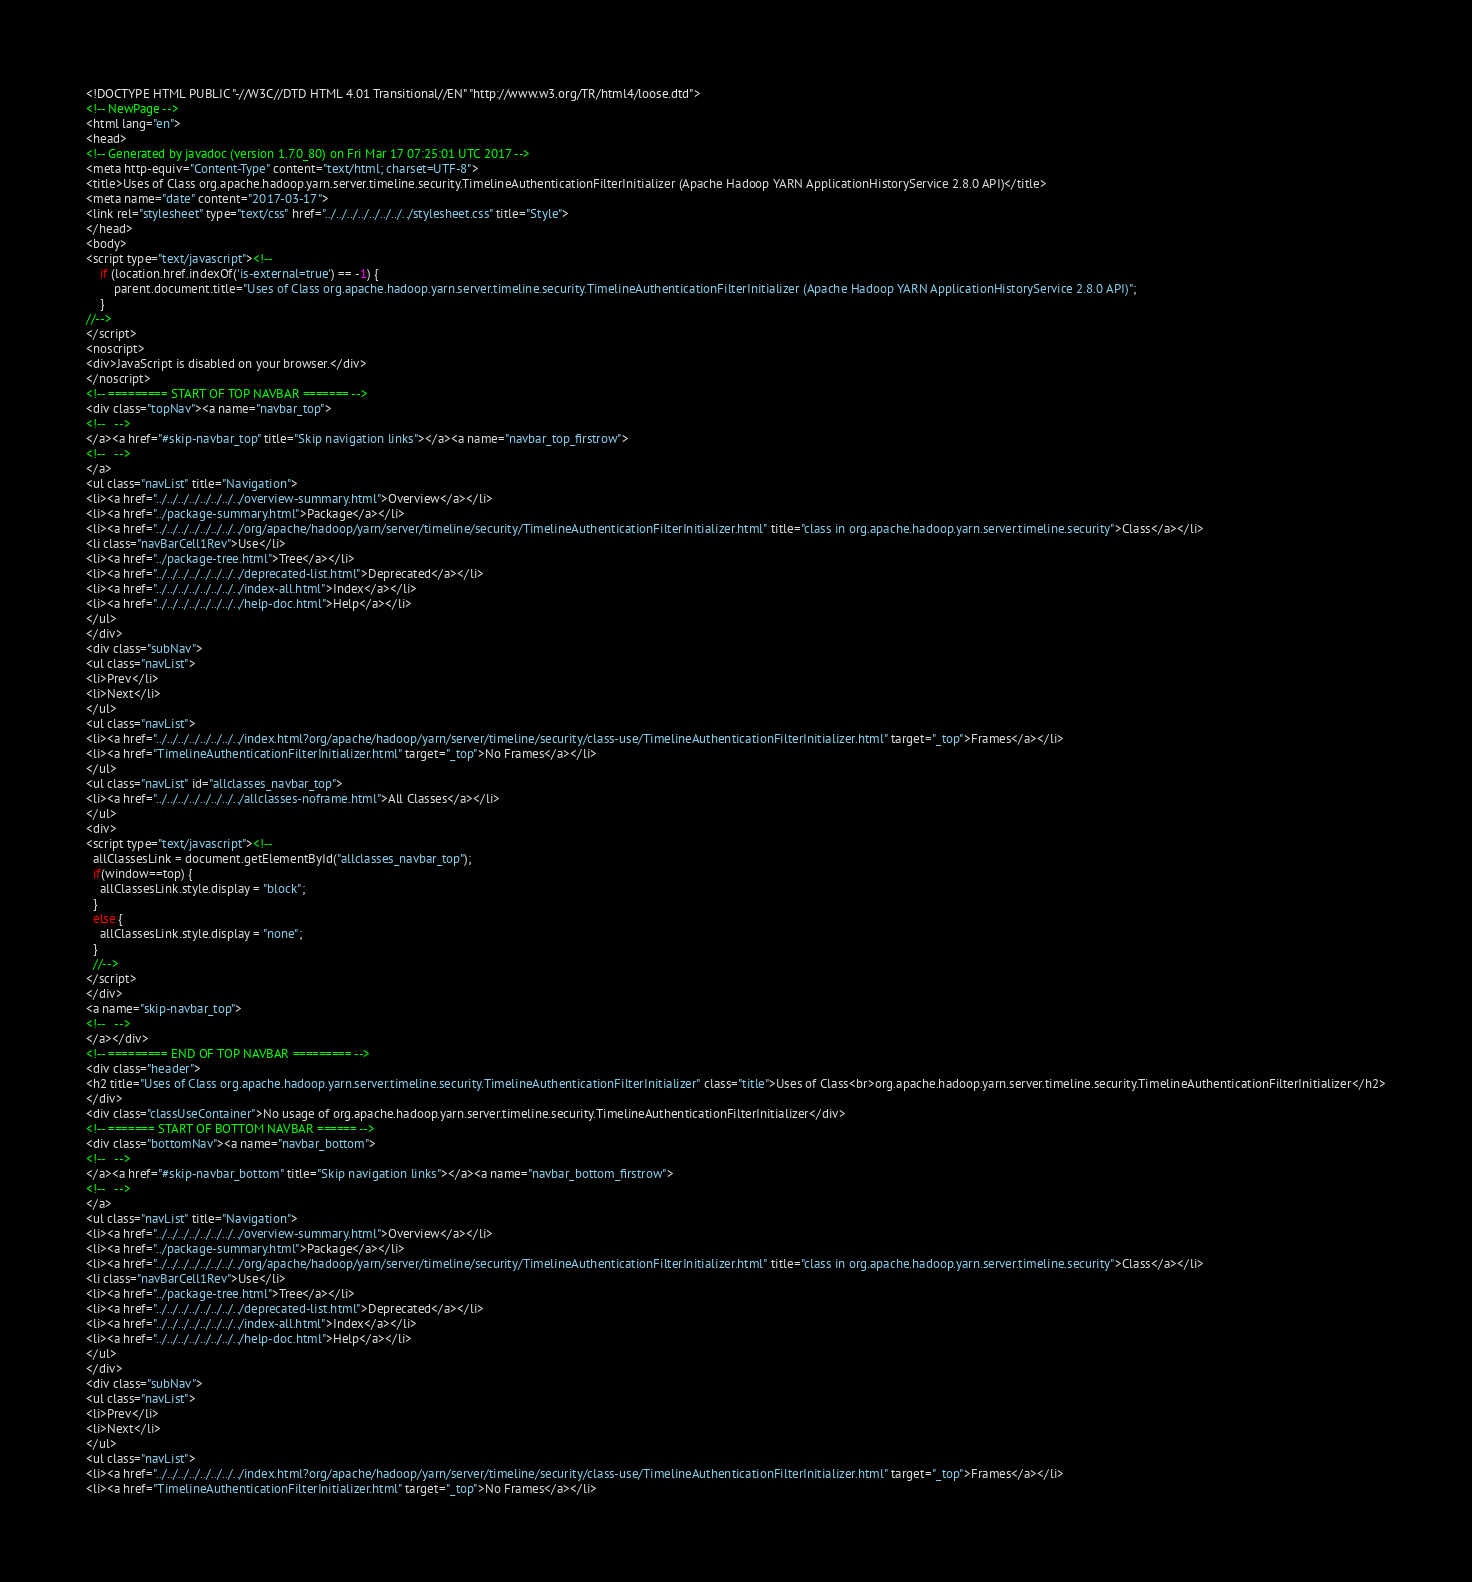Convert code to text. <code><loc_0><loc_0><loc_500><loc_500><_HTML_><!DOCTYPE HTML PUBLIC "-//W3C//DTD HTML 4.01 Transitional//EN" "http://www.w3.org/TR/html4/loose.dtd">
<!-- NewPage -->
<html lang="en">
<head>
<!-- Generated by javadoc (version 1.7.0_80) on Fri Mar 17 07:25:01 UTC 2017 -->
<meta http-equiv="Content-Type" content="text/html; charset=UTF-8">
<title>Uses of Class org.apache.hadoop.yarn.server.timeline.security.TimelineAuthenticationFilterInitializer (Apache Hadoop YARN ApplicationHistoryService 2.8.0 API)</title>
<meta name="date" content="2017-03-17">
<link rel="stylesheet" type="text/css" href="../../../../../../../../stylesheet.css" title="Style">
</head>
<body>
<script type="text/javascript"><!--
    if (location.href.indexOf('is-external=true') == -1) {
        parent.document.title="Uses of Class org.apache.hadoop.yarn.server.timeline.security.TimelineAuthenticationFilterInitializer (Apache Hadoop YARN ApplicationHistoryService 2.8.0 API)";
    }
//-->
</script>
<noscript>
<div>JavaScript is disabled on your browser.</div>
</noscript>
<!-- ========= START OF TOP NAVBAR ======= -->
<div class="topNav"><a name="navbar_top">
<!--   -->
</a><a href="#skip-navbar_top" title="Skip navigation links"></a><a name="navbar_top_firstrow">
<!--   -->
</a>
<ul class="navList" title="Navigation">
<li><a href="../../../../../../../../overview-summary.html">Overview</a></li>
<li><a href="../package-summary.html">Package</a></li>
<li><a href="../../../../../../../../org/apache/hadoop/yarn/server/timeline/security/TimelineAuthenticationFilterInitializer.html" title="class in org.apache.hadoop.yarn.server.timeline.security">Class</a></li>
<li class="navBarCell1Rev">Use</li>
<li><a href="../package-tree.html">Tree</a></li>
<li><a href="../../../../../../../../deprecated-list.html">Deprecated</a></li>
<li><a href="../../../../../../../../index-all.html">Index</a></li>
<li><a href="../../../../../../../../help-doc.html">Help</a></li>
</ul>
</div>
<div class="subNav">
<ul class="navList">
<li>Prev</li>
<li>Next</li>
</ul>
<ul class="navList">
<li><a href="../../../../../../../../index.html?org/apache/hadoop/yarn/server/timeline/security/class-use/TimelineAuthenticationFilterInitializer.html" target="_top">Frames</a></li>
<li><a href="TimelineAuthenticationFilterInitializer.html" target="_top">No Frames</a></li>
</ul>
<ul class="navList" id="allclasses_navbar_top">
<li><a href="../../../../../../../../allclasses-noframe.html">All Classes</a></li>
</ul>
<div>
<script type="text/javascript"><!--
  allClassesLink = document.getElementById("allclasses_navbar_top");
  if(window==top) {
    allClassesLink.style.display = "block";
  }
  else {
    allClassesLink.style.display = "none";
  }
  //-->
</script>
</div>
<a name="skip-navbar_top">
<!--   -->
</a></div>
<!-- ========= END OF TOP NAVBAR ========= -->
<div class="header">
<h2 title="Uses of Class org.apache.hadoop.yarn.server.timeline.security.TimelineAuthenticationFilterInitializer" class="title">Uses of Class<br>org.apache.hadoop.yarn.server.timeline.security.TimelineAuthenticationFilterInitializer</h2>
</div>
<div class="classUseContainer">No usage of org.apache.hadoop.yarn.server.timeline.security.TimelineAuthenticationFilterInitializer</div>
<!-- ======= START OF BOTTOM NAVBAR ====== -->
<div class="bottomNav"><a name="navbar_bottom">
<!--   -->
</a><a href="#skip-navbar_bottom" title="Skip navigation links"></a><a name="navbar_bottom_firstrow">
<!--   -->
</a>
<ul class="navList" title="Navigation">
<li><a href="../../../../../../../../overview-summary.html">Overview</a></li>
<li><a href="../package-summary.html">Package</a></li>
<li><a href="../../../../../../../../org/apache/hadoop/yarn/server/timeline/security/TimelineAuthenticationFilterInitializer.html" title="class in org.apache.hadoop.yarn.server.timeline.security">Class</a></li>
<li class="navBarCell1Rev">Use</li>
<li><a href="../package-tree.html">Tree</a></li>
<li><a href="../../../../../../../../deprecated-list.html">Deprecated</a></li>
<li><a href="../../../../../../../../index-all.html">Index</a></li>
<li><a href="../../../../../../../../help-doc.html">Help</a></li>
</ul>
</div>
<div class="subNav">
<ul class="navList">
<li>Prev</li>
<li>Next</li>
</ul>
<ul class="navList">
<li><a href="../../../../../../../../index.html?org/apache/hadoop/yarn/server/timeline/security/class-use/TimelineAuthenticationFilterInitializer.html" target="_top">Frames</a></li>
<li><a href="TimelineAuthenticationFilterInitializer.html" target="_top">No Frames</a></li></code> 